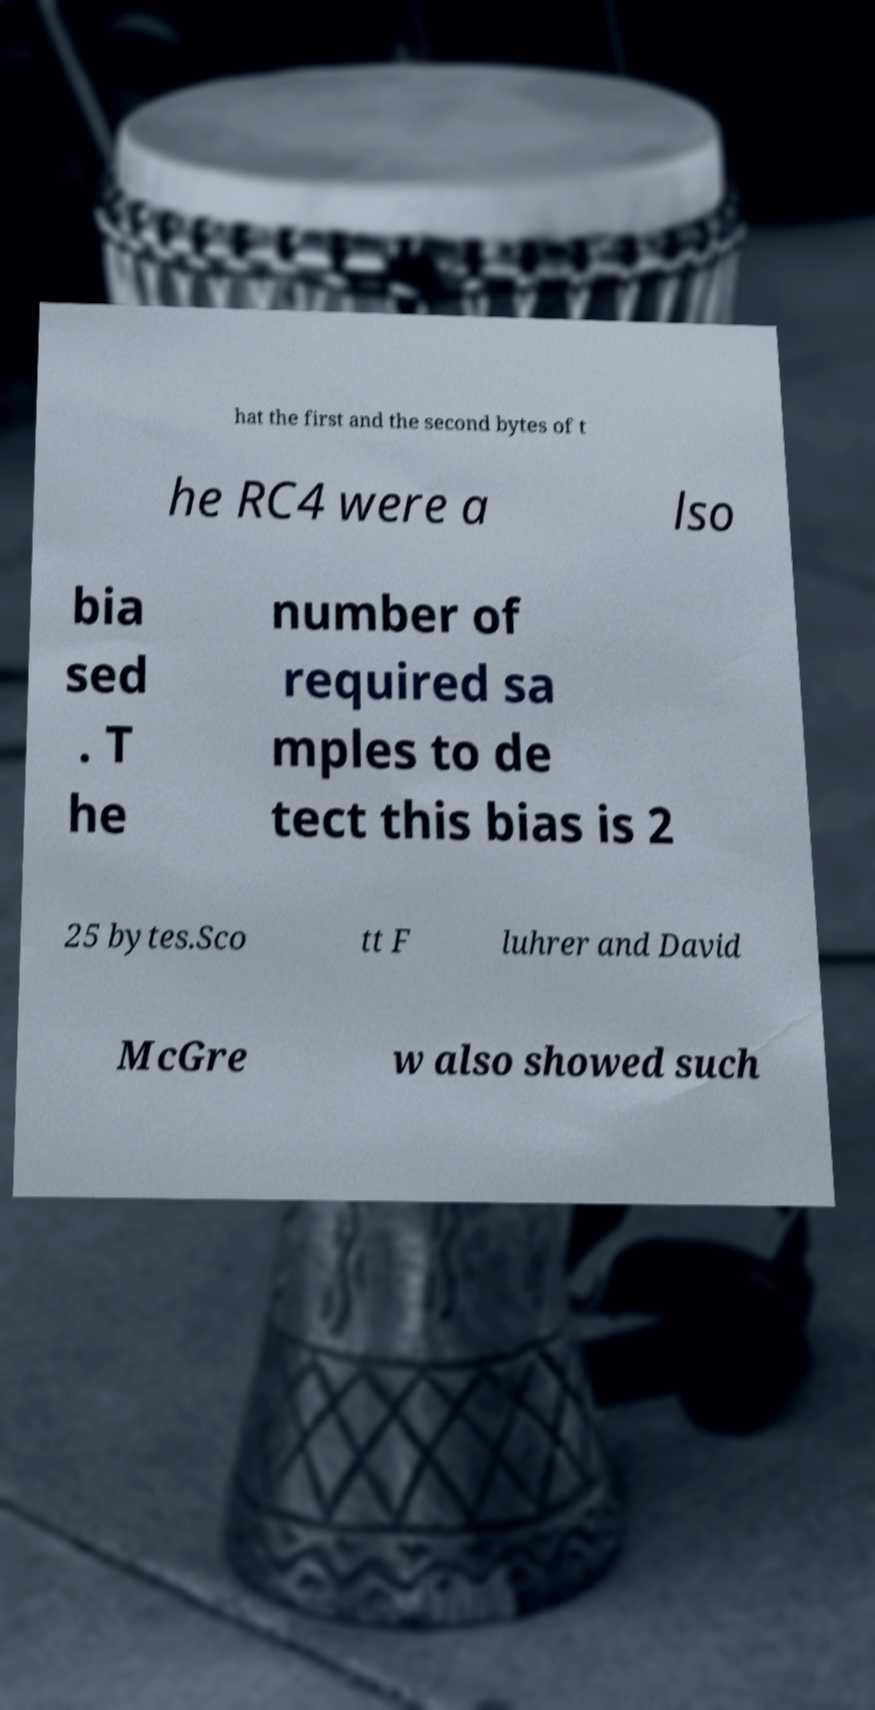Could you assist in decoding the text presented in this image and type it out clearly? hat the first and the second bytes of t he RC4 were a lso bia sed . T he number of required sa mples to de tect this bias is 2 25 bytes.Sco tt F luhrer and David McGre w also showed such 